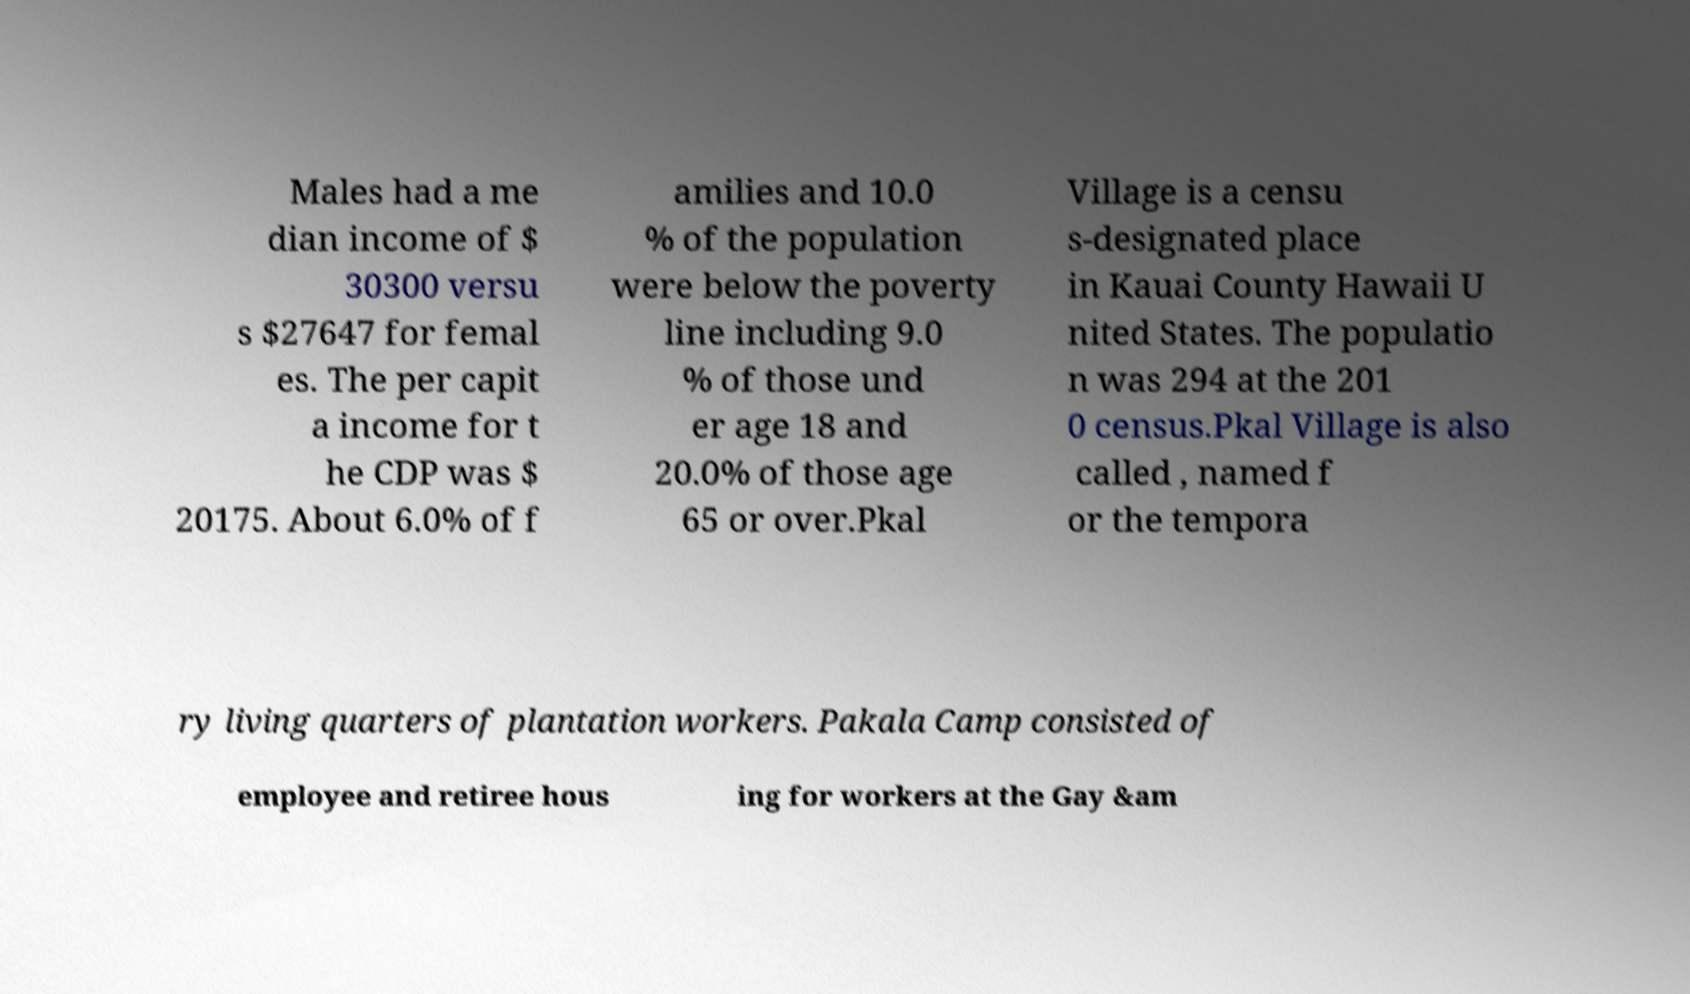Can you read and provide the text displayed in the image?This photo seems to have some interesting text. Can you extract and type it out for me? Males had a me dian income of $ 30300 versu s $27647 for femal es. The per capit a income for t he CDP was $ 20175. About 6.0% of f amilies and 10.0 % of the population were below the poverty line including 9.0 % of those und er age 18 and 20.0% of those age 65 or over.Pkal Village is a censu s-designated place in Kauai County Hawaii U nited States. The populatio n was 294 at the 201 0 census.Pkal Village is also called , named f or the tempora ry living quarters of plantation workers. Pakala Camp consisted of employee and retiree hous ing for workers at the Gay &am 